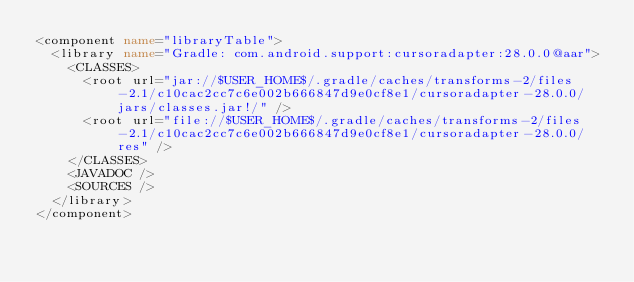Convert code to text. <code><loc_0><loc_0><loc_500><loc_500><_XML_><component name="libraryTable">
  <library name="Gradle: com.android.support:cursoradapter:28.0.0@aar">
    <CLASSES>
      <root url="jar://$USER_HOME$/.gradle/caches/transforms-2/files-2.1/c10cac2cc7c6e002b666847d9e0cf8e1/cursoradapter-28.0.0/jars/classes.jar!/" />
      <root url="file://$USER_HOME$/.gradle/caches/transforms-2/files-2.1/c10cac2cc7c6e002b666847d9e0cf8e1/cursoradapter-28.0.0/res" />
    </CLASSES>
    <JAVADOC />
    <SOURCES />
  </library>
</component></code> 